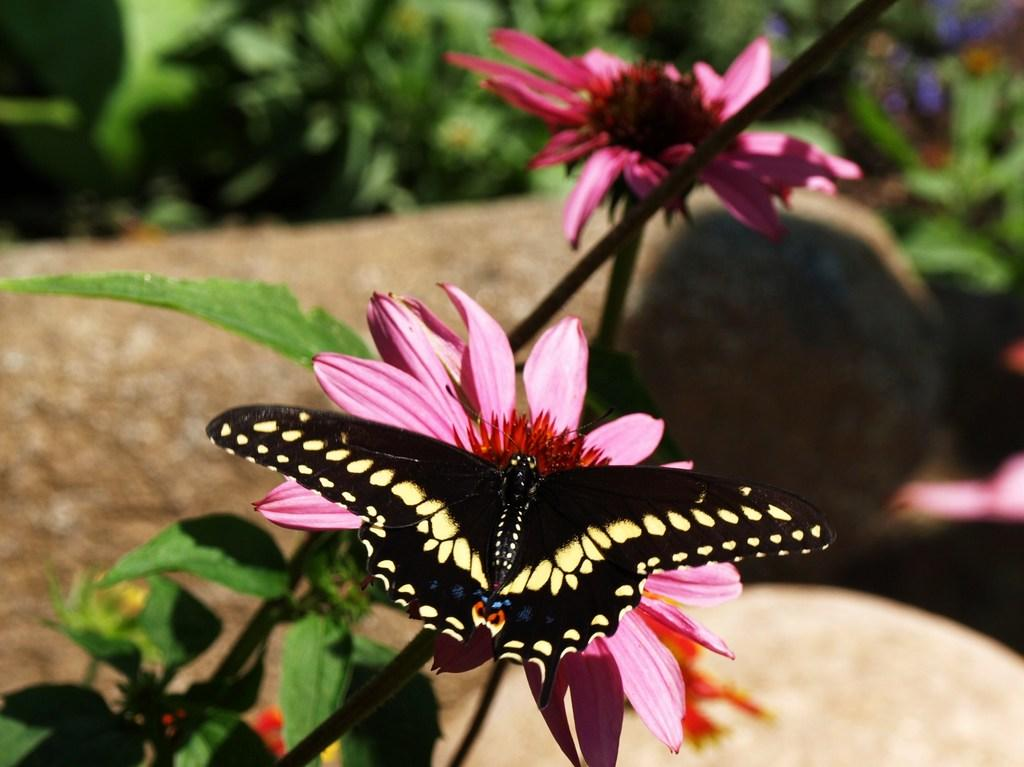How many flowers are on the plant in the image? There are two flowers on the plant in the image. What is present on one of the flowers? There is a butterfly on one of the flowers in the image. What invention can be seen in the image? There is no invention present in the image; it features a plant with flowers and a butterfly. What part of the body is visible in the image? There is no part of the body present in the image; it features a plant with flowers and a butterfly. 